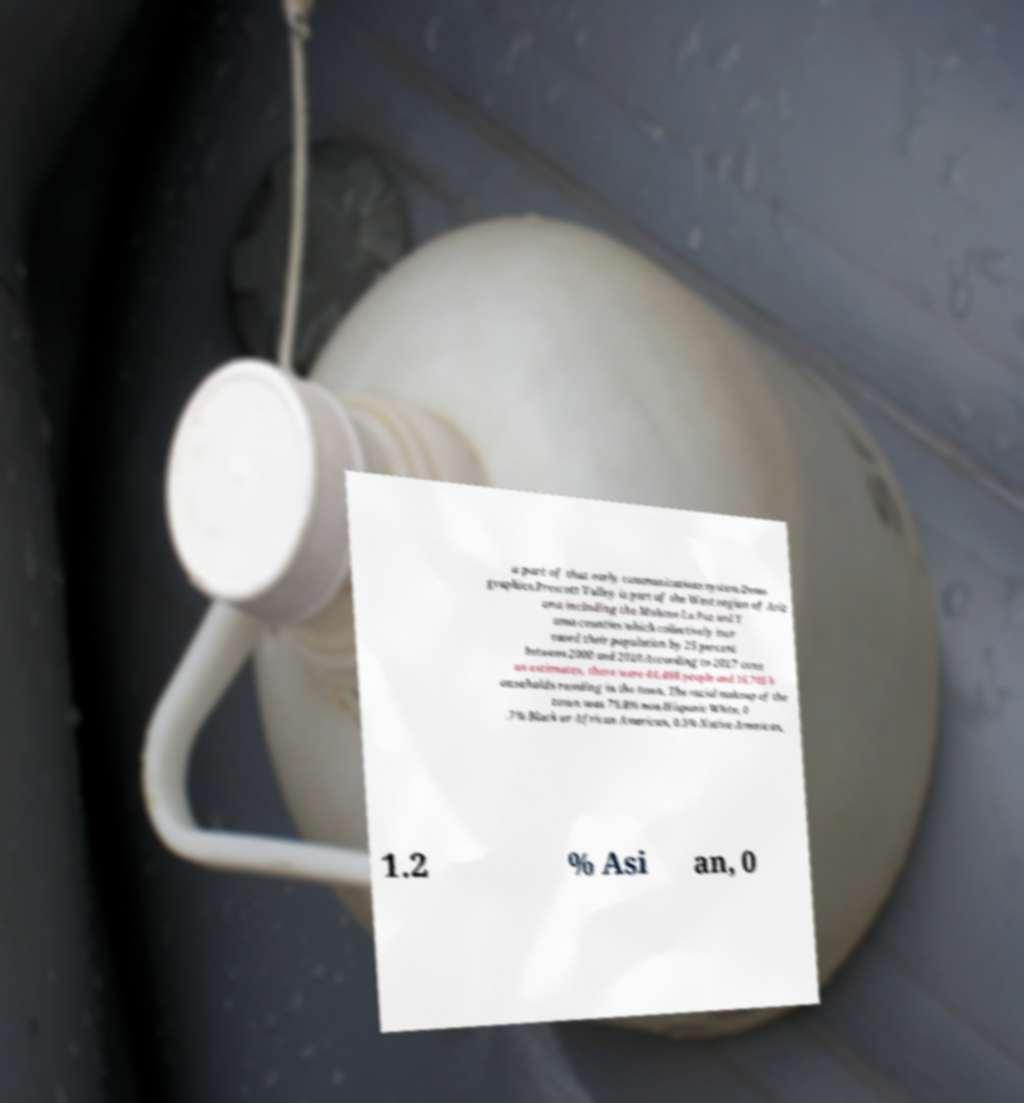Could you extract and type out the text from this image? a part of that early communications system.Demo graphics.Prescott Valley is part of the West region of Ariz ona including the Mohave La Paz and Y uma counties which collectively incr eased their population by 25 percent between 2000 and 2010.According to 2017 cens us estimates, there were 44,466 people and 16,705 h ouseholds residing in the town. The racial makeup of the town was 76.8% non-Hispanic White, 0 .7% Black or African American, 0.5% Native American, 1.2 % Asi an, 0 